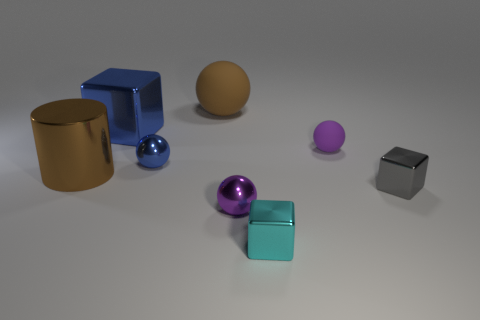The blue sphere that is made of the same material as the cyan object is what size?
Give a very brief answer. Small. Is the color of the rubber thing left of the small cyan object the same as the large thing in front of the purple matte thing?
Give a very brief answer. Yes. Is the color of the sphere in front of the metallic cylinder the same as the tiny matte sphere?
Offer a terse response. Yes. How many rubber things are gray objects or tiny cubes?
Provide a short and direct response. 0. What is the shape of the tiny purple matte thing?
Offer a very short reply. Sphere. Are the large ball and the big cube made of the same material?
Provide a succinct answer. No. Is there a cylinder that is right of the brown thing behind the block behind the small blue ball?
Your answer should be compact. No. How many other objects are there of the same shape as the small blue thing?
Give a very brief answer. 3. What is the shape of the tiny shiny thing that is on the left side of the tiny cyan metal object and in front of the brown cylinder?
Provide a short and direct response. Sphere. There is a matte thing that is behind the blue thing left of the blue thing in front of the large blue metallic block; what is its color?
Your response must be concise. Brown. 